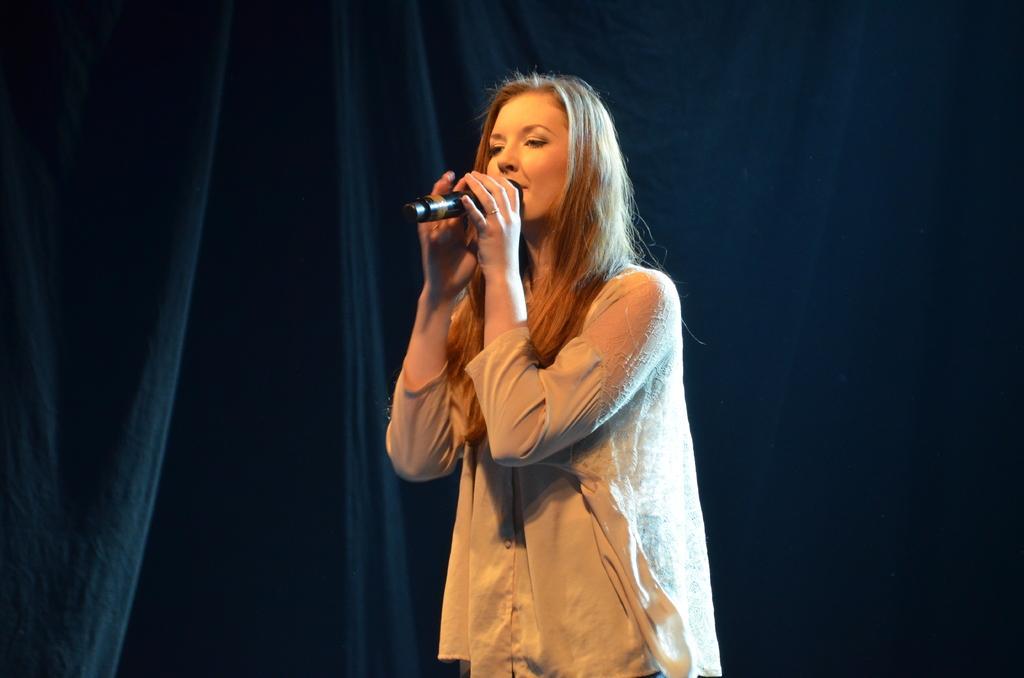Could you give a brief overview of what you see in this image? As we can see in the image there is a woman holding mic. 